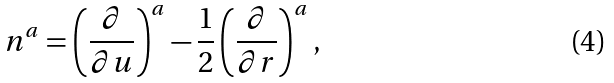Convert formula to latex. <formula><loc_0><loc_0><loc_500><loc_500>n ^ { a } = \left ( \frac { \partial } { \partial u } \right ) ^ { a } - \frac { 1 } { 2 } \left ( \frac { \partial } { \partial r } \right ) ^ { a } ,</formula> 